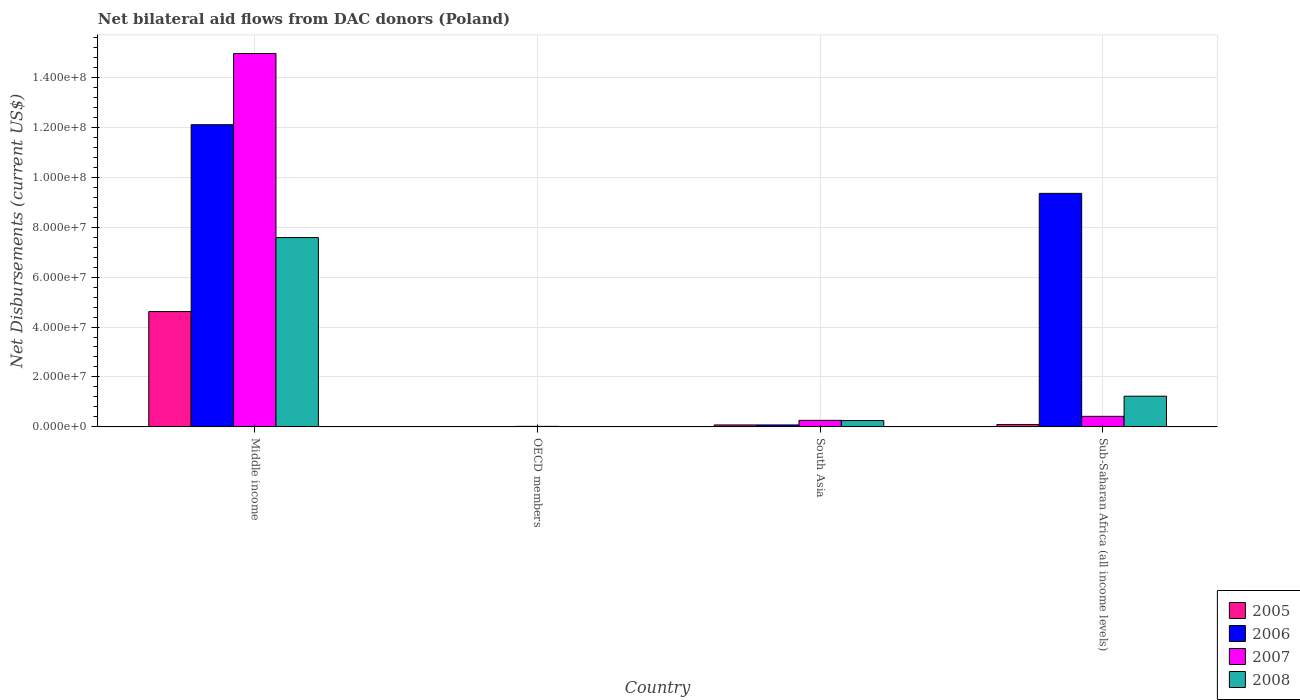How many bars are there on the 2nd tick from the left?
Ensure brevity in your answer.  4. In how many cases, is the number of bars for a given country not equal to the number of legend labels?
Offer a very short reply. 0. What is the net bilateral aid flows in 2006 in Middle income?
Provide a short and direct response. 1.21e+08. Across all countries, what is the maximum net bilateral aid flows in 2005?
Keep it short and to the point. 4.62e+07. Across all countries, what is the minimum net bilateral aid flows in 2005?
Offer a terse response. 5.00e+04. What is the total net bilateral aid flows in 2006 in the graph?
Your answer should be very brief. 2.15e+08. What is the difference between the net bilateral aid flows in 2005 in Middle income and that in Sub-Saharan Africa (all income levels)?
Make the answer very short. 4.52e+07. What is the difference between the net bilateral aid flows in 2007 in OECD members and the net bilateral aid flows in 2006 in South Asia?
Ensure brevity in your answer.  -5.60e+05. What is the average net bilateral aid flows in 2005 per country?
Your response must be concise. 1.20e+07. What is the difference between the net bilateral aid flows of/in 2005 and net bilateral aid flows of/in 2007 in Sub-Saharan Africa (all income levels)?
Provide a short and direct response. -3.26e+06. In how many countries, is the net bilateral aid flows in 2007 greater than 80000000 US$?
Provide a succinct answer. 1. What is the ratio of the net bilateral aid flows in 2008 in South Asia to that in Sub-Saharan Africa (all income levels)?
Offer a very short reply. 0.21. Is the net bilateral aid flows in 2007 in Middle income less than that in Sub-Saharan Africa (all income levels)?
Ensure brevity in your answer.  No. What is the difference between the highest and the second highest net bilateral aid flows in 2006?
Offer a terse response. 2.75e+07. What is the difference between the highest and the lowest net bilateral aid flows in 2008?
Your response must be concise. 7.57e+07. Is the sum of the net bilateral aid flows in 2008 in OECD members and Sub-Saharan Africa (all income levels) greater than the maximum net bilateral aid flows in 2006 across all countries?
Give a very brief answer. No. Is it the case that in every country, the sum of the net bilateral aid flows in 2006 and net bilateral aid flows in 2007 is greater than the net bilateral aid flows in 2005?
Your answer should be very brief. Yes. Are all the bars in the graph horizontal?
Ensure brevity in your answer.  No. How many countries are there in the graph?
Offer a very short reply. 4. Are the values on the major ticks of Y-axis written in scientific E-notation?
Give a very brief answer. Yes. Does the graph contain grids?
Keep it short and to the point. Yes. Where does the legend appear in the graph?
Keep it short and to the point. Bottom right. How many legend labels are there?
Your response must be concise. 4. What is the title of the graph?
Offer a very short reply. Net bilateral aid flows from DAC donors (Poland). What is the label or title of the X-axis?
Make the answer very short. Country. What is the label or title of the Y-axis?
Provide a succinct answer. Net Disbursements (current US$). What is the Net Disbursements (current US$) of 2005 in Middle income?
Offer a very short reply. 4.62e+07. What is the Net Disbursements (current US$) of 2006 in Middle income?
Make the answer very short. 1.21e+08. What is the Net Disbursements (current US$) of 2007 in Middle income?
Give a very brief answer. 1.50e+08. What is the Net Disbursements (current US$) of 2008 in Middle income?
Keep it short and to the point. 7.58e+07. What is the Net Disbursements (current US$) in 2005 in OECD members?
Your answer should be very brief. 5.00e+04. What is the Net Disbursements (current US$) of 2006 in OECD members?
Provide a succinct answer. 3.00e+04. What is the Net Disbursements (current US$) in 2007 in OECD members?
Your answer should be compact. 2.10e+05. What is the Net Disbursements (current US$) of 2005 in South Asia?
Offer a very short reply. 7.70e+05. What is the Net Disbursements (current US$) in 2006 in South Asia?
Your answer should be compact. 7.70e+05. What is the Net Disbursements (current US$) of 2007 in South Asia?
Offer a very short reply. 2.61e+06. What is the Net Disbursements (current US$) of 2008 in South Asia?
Make the answer very short. 2.54e+06. What is the Net Disbursements (current US$) of 2005 in Sub-Saharan Africa (all income levels)?
Your response must be concise. 9.60e+05. What is the Net Disbursements (current US$) of 2006 in Sub-Saharan Africa (all income levels)?
Provide a short and direct response. 9.35e+07. What is the Net Disbursements (current US$) in 2007 in Sub-Saharan Africa (all income levels)?
Keep it short and to the point. 4.22e+06. What is the Net Disbursements (current US$) of 2008 in Sub-Saharan Africa (all income levels)?
Ensure brevity in your answer.  1.23e+07. Across all countries, what is the maximum Net Disbursements (current US$) in 2005?
Your answer should be compact. 4.62e+07. Across all countries, what is the maximum Net Disbursements (current US$) of 2006?
Provide a succinct answer. 1.21e+08. Across all countries, what is the maximum Net Disbursements (current US$) of 2007?
Provide a short and direct response. 1.50e+08. Across all countries, what is the maximum Net Disbursements (current US$) of 2008?
Give a very brief answer. 7.58e+07. Across all countries, what is the minimum Net Disbursements (current US$) in 2008?
Your answer should be very brief. 1.40e+05. What is the total Net Disbursements (current US$) in 2005 in the graph?
Make the answer very short. 4.80e+07. What is the total Net Disbursements (current US$) in 2006 in the graph?
Offer a very short reply. 2.15e+08. What is the total Net Disbursements (current US$) in 2007 in the graph?
Make the answer very short. 1.57e+08. What is the total Net Disbursements (current US$) in 2008 in the graph?
Your answer should be compact. 9.08e+07. What is the difference between the Net Disbursements (current US$) in 2005 in Middle income and that in OECD members?
Your answer should be compact. 4.61e+07. What is the difference between the Net Disbursements (current US$) of 2006 in Middle income and that in OECD members?
Give a very brief answer. 1.21e+08. What is the difference between the Net Disbursements (current US$) in 2007 in Middle income and that in OECD members?
Give a very brief answer. 1.49e+08. What is the difference between the Net Disbursements (current US$) of 2008 in Middle income and that in OECD members?
Provide a short and direct response. 7.57e+07. What is the difference between the Net Disbursements (current US$) in 2005 in Middle income and that in South Asia?
Provide a succinct answer. 4.54e+07. What is the difference between the Net Disbursements (current US$) in 2006 in Middle income and that in South Asia?
Keep it short and to the point. 1.20e+08. What is the difference between the Net Disbursements (current US$) in 2007 in Middle income and that in South Asia?
Make the answer very short. 1.47e+08. What is the difference between the Net Disbursements (current US$) of 2008 in Middle income and that in South Asia?
Your answer should be very brief. 7.33e+07. What is the difference between the Net Disbursements (current US$) in 2005 in Middle income and that in Sub-Saharan Africa (all income levels)?
Provide a short and direct response. 4.52e+07. What is the difference between the Net Disbursements (current US$) of 2006 in Middle income and that in Sub-Saharan Africa (all income levels)?
Give a very brief answer. 2.75e+07. What is the difference between the Net Disbursements (current US$) in 2007 in Middle income and that in Sub-Saharan Africa (all income levels)?
Give a very brief answer. 1.45e+08. What is the difference between the Net Disbursements (current US$) of 2008 in Middle income and that in Sub-Saharan Africa (all income levels)?
Provide a succinct answer. 6.35e+07. What is the difference between the Net Disbursements (current US$) in 2005 in OECD members and that in South Asia?
Ensure brevity in your answer.  -7.20e+05. What is the difference between the Net Disbursements (current US$) in 2006 in OECD members and that in South Asia?
Give a very brief answer. -7.40e+05. What is the difference between the Net Disbursements (current US$) of 2007 in OECD members and that in South Asia?
Your response must be concise. -2.40e+06. What is the difference between the Net Disbursements (current US$) in 2008 in OECD members and that in South Asia?
Ensure brevity in your answer.  -2.40e+06. What is the difference between the Net Disbursements (current US$) in 2005 in OECD members and that in Sub-Saharan Africa (all income levels)?
Provide a succinct answer. -9.10e+05. What is the difference between the Net Disbursements (current US$) of 2006 in OECD members and that in Sub-Saharan Africa (all income levels)?
Provide a succinct answer. -9.35e+07. What is the difference between the Net Disbursements (current US$) in 2007 in OECD members and that in Sub-Saharan Africa (all income levels)?
Make the answer very short. -4.01e+06. What is the difference between the Net Disbursements (current US$) of 2008 in OECD members and that in Sub-Saharan Africa (all income levels)?
Keep it short and to the point. -1.22e+07. What is the difference between the Net Disbursements (current US$) in 2006 in South Asia and that in Sub-Saharan Africa (all income levels)?
Ensure brevity in your answer.  -9.28e+07. What is the difference between the Net Disbursements (current US$) in 2007 in South Asia and that in Sub-Saharan Africa (all income levels)?
Your response must be concise. -1.61e+06. What is the difference between the Net Disbursements (current US$) in 2008 in South Asia and that in Sub-Saharan Africa (all income levels)?
Provide a succinct answer. -9.75e+06. What is the difference between the Net Disbursements (current US$) in 2005 in Middle income and the Net Disbursements (current US$) in 2006 in OECD members?
Your response must be concise. 4.62e+07. What is the difference between the Net Disbursements (current US$) in 2005 in Middle income and the Net Disbursements (current US$) in 2007 in OECD members?
Ensure brevity in your answer.  4.60e+07. What is the difference between the Net Disbursements (current US$) in 2005 in Middle income and the Net Disbursements (current US$) in 2008 in OECD members?
Provide a succinct answer. 4.60e+07. What is the difference between the Net Disbursements (current US$) in 2006 in Middle income and the Net Disbursements (current US$) in 2007 in OECD members?
Give a very brief answer. 1.21e+08. What is the difference between the Net Disbursements (current US$) in 2006 in Middle income and the Net Disbursements (current US$) in 2008 in OECD members?
Your answer should be very brief. 1.21e+08. What is the difference between the Net Disbursements (current US$) in 2007 in Middle income and the Net Disbursements (current US$) in 2008 in OECD members?
Ensure brevity in your answer.  1.49e+08. What is the difference between the Net Disbursements (current US$) in 2005 in Middle income and the Net Disbursements (current US$) in 2006 in South Asia?
Provide a short and direct response. 4.54e+07. What is the difference between the Net Disbursements (current US$) in 2005 in Middle income and the Net Disbursements (current US$) in 2007 in South Asia?
Your response must be concise. 4.36e+07. What is the difference between the Net Disbursements (current US$) of 2005 in Middle income and the Net Disbursements (current US$) of 2008 in South Asia?
Your answer should be very brief. 4.36e+07. What is the difference between the Net Disbursements (current US$) of 2006 in Middle income and the Net Disbursements (current US$) of 2007 in South Asia?
Provide a short and direct response. 1.18e+08. What is the difference between the Net Disbursements (current US$) of 2006 in Middle income and the Net Disbursements (current US$) of 2008 in South Asia?
Give a very brief answer. 1.18e+08. What is the difference between the Net Disbursements (current US$) in 2007 in Middle income and the Net Disbursements (current US$) in 2008 in South Asia?
Your answer should be compact. 1.47e+08. What is the difference between the Net Disbursements (current US$) of 2005 in Middle income and the Net Disbursements (current US$) of 2006 in Sub-Saharan Africa (all income levels)?
Provide a short and direct response. -4.74e+07. What is the difference between the Net Disbursements (current US$) of 2005 in Middle income and the Net Disbursements (current US$) of 2007 in Sub-Saharan Africa (all income levels)?
Provide a short and direct response. 4.20e+07. What is the difference between the Net Disbursements (current US$) in 2005 in Middle income and the Net Disbursements (current US$) in 2008 in Sub-Saharan Africa (all income levels)?
Your answer should be compact. 3.39e+07. What is the difference between the Net Disbursements (current US$) in 2006 in Middle income and the Net Disbursements (current US$) in 2007 in Sub-Saharan Africa (all income levels)?
Offer a very short reply. 1.17e+08. What is the difference between the Net Disbursements (current US$) in 2006 in Middle income and the Net Disbursements (current US$) in 2008 in Sub-Saharan Africa (all income levels)?
Make the answer very short. 1.09e+08. What is the difference between the Net Disbursements (current US$) in 2007 in Middle income and the Net Disbursements (current US$) in 2008 in Sub-Saharan Africa (all income levels)?
Give a very brief answer. 1.37e+08. What is the difference between the Net Disbursements (current US$) in 2005 in OECD members and the Net Disbursements (current US$) in 2006 in South Asia?
Your response must be concise. -7.20e+05. What is the difference between the Net Disbursements (current US$) in 2005 in OECD members and the Net Disbursements (current US$) in 2007 in South Asia?
Ensure brevity in your answer.  -2.56e+06. What is the difference between the Net Disbursements (current US$) in 2005 in OECD members and the Net Disbursements (current US$) in 2008 in South Asia?
Keep it short and to the point. -2.49e+06. What is the difference between the Net Disbursements (current US$) of 2006 in OECD members and the Net Disbursements (current US$) of 2007 in South Asia?
Make the answer very short. -2.58e+06. What is the difference between the Net Disbursements (current US$) of 2006 in OECD members and the Net Disbursements (current US$) of 2008 in South Asia?
Ensure brevity in your answer.  -2.51e+06. What is the difference between the Net Disbursements (current US$) of 2007 in OECD members and the Net Disbursements (current US$) of 2008 in South Asia?
Give a very brief answer. -2.33e+06. What is the difference between the Net Disbursements (current US$) in 2005 in OECD members and the Net Disbursements (current US$) in 2006 in Sub-Saharan Africa (all income levels)?
Your answer should be compact. -9.35e+07. What is the difference between the Net Disbursements (current US$) in 2005 in OECD members and the Net Disbursements (current US$) in 2007 in Sub-Saharan Africa (all income levels)?
Keep it short and to the point. -4.17e+06. What is the difference between the Net Disbursements (current US$) in 2005 in OECD members and the Net Disbursements (current US$) in 2008 in Sub-Saharan Africa (all income levels)?
Offer a terse response. -1.22e+07. What is the difference between the Net Disbursements (current US$) of 2006 in OECD members and the Net Disbursements (current US$) of 2007 in Sub-Saharan Africa (all income levels)?
Keep it short and to the point. -4.19e+06. What is the difference between the Net Disbursements (current US$) of 2006 in OECD members and the Net Disbursements (current US$) of 2008 in Sub-Saharan Africa (all income levels)?
Offer a very short reply. -1.23e+07. What is the difference between the Net Disbursements (current US$) in 2007 in OECD members and the Net Disbursements (current US$) in 2008 in Sub-Saharan Africa (all income levels)?
Give a very brief answer. -1.21e+07. What is the difference between the Net Disbursements (current US$) of 2005 in South Asia and the Net Disbursements (current US$) of 2006 in Sub-Saharan Africa (all income levels)?
Give a very brief answer. -9.28e+07. What is the difference between the Net Disbursements (current US$) in 2005 in South Asia and the Net Disbursements (current US$) in 2007 in Sub-Saharan Africa (all income levels)?
Offer a terse response. -3.45e+06. What is the difference between the Net Disbursements (current US$) in 2005 in South Asia and the Net Disbursements (current US$) in 2008 in Sub-Saharan Africa (all income levels)?
Provide a succinct answer. -1.15e+07. What is the difference between the Net Disbursements (current US$) of 2006 in South Asia and the Net Disbursements (current US$) of 2007 in Sub-Saharan Africa (all income levels)?
Provide a short and direct response. -3.45e+06. What is the difference between the Net Disbursements (current US$) in 2006 in South Asia and the Net Disbursements (current US$) in 2008 in Sub-Saharan Africa (all income levels)?
Your answer should be compact. -1.15e+07. What is the difference between the Net Disbursements (current US$) in 2007 in South Asia and the Net Disbursements (current US$) in 2008 in Sub-Saharan Africa (all income levels)?
Make the answer very short. -9.68e+06. What is the average Net Disbursements (current US$) in 2005 per country?
Give a very brief answer. 1.20e+07. What is the average Net Disbursements (current US$) of 2006 per country?
Keep it short and to the point. 5.38e+07. What is the average Net Disbursements (current US$) in 2007 per country?
Offer a terse response. 3.91e+07. What is the average Net Disbursements (current US$) in 2008 per country?
Offer a terse response. 2.27e+07. What is the difference between the Net Disbursements (current US$) in 2005 and Net Disbursements (current US$) in 2006 in Middle income?
Provide a short and direct response. -7.48e+07. What is the difference between the Net Disbursements (current US$) of 2005 and Net Disbursements (current US$) of 2007 in Middle income?
Give a very brief answer. -1.03e+08. What is the difference between the Net Disbursements (current US$) in 2005 and Net Disbursements (current US$) in 2008 in Middle income?
Your answer should be compact. -2.96e+07. What is the difference between the Net Disbursements (current US$) of 2006 and Net Disbursements (current US$) of 2007 in Middle income?
Offer a terse response. -2.85e+07. What is the difference between the Net Disbursements (current US$) of 2006 and Net Disbursements (current US$) of 2008 in Middle income?
Ensure brevity in your answer.  4.52e+07. What is the difference between the Net Disbursements (current US$) in 2007 and Net Disbursements (current US$) in 2008 in Middle income?
Provide a succinct answer. 7.37e+07. What is the difference between the Net Disbursements (current US$) in 2005 and Net Disbursements (current US$) in 2007 in OECD members?
Your answer should be very brief. -1.60e+05. What is the difference between the Net Disbursements (current US$) in 2006 and Net Disbursements (current US$) in 2008 in OECD members?
Provide a short and direct response. -1.10e+05. What is the difference between the Net Disbursements (current US$) in 2007 and Net Disbursements (current US$) in 2008 in OECD members?
Keep it short and to the point. 7.00e+04. What is the difference between the Net Disbursements (current US$) in 2005 and Net Disbursements (current US$) in 2006 in South Asia?
Make the answer very short. 0. What is the difference between the Net Disbursements (current US$) of 2005 and Net Disbursements (current US$) of 2007 in South Asia?
Provide a succinct answer. -1.84e+06. What is the difference between the Net Disbursements (current US$) in 2005 and Net Disbursements (current US$) in 2008 in South Asia?
Ensure brevity in your answer.  -1.77e+06. What is the difference between the Net Disbursements (current US$) in 2006 and Net Disbursements (current US$) in 2007 in South Asia?
Offer a very short reply. -1.84e+06. What is the difference between the Net Disbursements (current US$) of 2006 and Net Disbursements (current US$) of 2008 in South Asia?
Your answer should be compact. -1.77e+06. What is the difference between the Net Disbursements (current US$) of 2007 and Net Disbursements (current US$) of 2008 in South Asia?
Ensure brevity in your answer.  7.00e+04. What is the difference between the Net Disbursements (current US$) of 2005 and Net Disbursements (current US$) of 2006 in Sub-Saharan Africa (all income levels)?
Offer a terse response. -9.26e+07. What is the difference between the Net Disbursements (current US$) in 2005 and Net Disbursements (current US$) in 2007 in Sub-Saharan Africa (all income levels)?
Give a very brief answer. -3.26e+06. What is the difference between the Net Disbursements (current US$) of 2005 and Net Disbursements (current US$) of 2008 in Sub-Saharan Africa (all income levels)?
Make the answer very short. -1.13e+07. What is the difference between the Net Disbursements (current US$) of 2006 and Net Disbursements (current US$) of 2007 in Sub-Saharan Africa (all income levels)?
Your answer should be very brief. 8.93e+07. What is the difference between the Net Disbursements (current US$) in 2006 and Net Disbursements (current US$) in 2008 in Sub-Saharan Africa (all income levels)?
Your answer should be compact. 8.12e+07. What is the difference between the Net Disbursements (current US$) in 2007 and Net Disbursements (current US$) in 2008 in Sub-Saharan Africa (all income levels)?
Provide a succinct answer. -8.07e+06. What is the ratio of the Net Disbursements (current US$) of 2005 in Middle income to that in OECD members?
Offer a terse response. 923.8. What is the ratio of the Net Disbursements (current US$) of 2006 in Middle income to that in OECD members?
Offer a very short reply. 4034.67. What is the ratio of the Net Disbursements (current US$) in 2007 in Middle income to that in OECD members?
Your answer should be compact. 712.14. What is the ratio of the Net Disbursements (current US$) in 2008 in Middle income to that in OECD members?
Provide a short and direct response. 541.64. What is the ratio of the Net Disbursements (current US$) of 2005 in Middle income to that in South Asia?
Provide a short and direct response. 59.99. What is the ratio of the Net Disbursements (current US$) in 2006 in Middle income to that in South Asia?
Provide a succinct answer. 157.19. What is the ratio of the Net Disbursements (current US$) of 2007 in Middle income to that in South Asia?
Your response must be concise. 57.3. What is the ratio of the Net Disbursements (current US$) of 2008 in Middle income to that in South Asia?
Give a very brief answer. 29.85. What is the ratio of the Net Disbursements (current US$) of 2005 in Middle income to that in Sub-Saharan Africa (all income levels)?
Ensure brevity in your answer.  48.11. What is the ratio of the Net Disbursements (current US$) in 2006 in Middle income to that in Sub-Saharan Africa (all income levels)?
Provide a short and direct response. 1.29. What is the ratio of the Net Disbursements (current US$) in 2007 in Middle income to that in Sub-Saharan Africa (all income levels)?
Provide a short and direct response. 35.44. What is the ratio of the Net Disbursements (current US$) of 2008 in Middle income to that in Sub-Saharan Africa (all income levels)?
Make the answer very short. 6.17. What is the ratio of the Net Disbursements (current US$) of 2005 in OECD members to that in South Asia?
Give a very brief answer. 0.06. What is the ratio of the Net Disbursements (current US$) of 2006 in OECD members to that in South Asia?
Your answer should be compact. 0.04. What is the ratio of the Net Disbursements (current US$) of 2007 in OECD members to that in South Asia?
Your answer should be compact. 0.08. What is the ratio of the Net Disbursements (current US$) in 2008 in OECD members to that in South Asia?
Make the answer very short. 0.06. What is the ratio of the Net Disbursements (current US$) of 2005 in OECD members to that in Sub-Saharan Africa (all income levels)?
Your answer should be very brief. 0.05. What is the ratio of the Net Disbursements (current US$) in 2007 in OECD members to that in Sub-Saharan Africa (all income levels)?
Your answer should be very brief. 0.05. What is the ratio of the Net Disbursements (current US$) of 2008 in OECD members to that in Sub-Saharan Africa (all income levels)?
Keep it short and to the point. 0.01. What is the ratio of the Net Disbursements (current US$) of 2005 in South Asia to that in Sub-Saharan Africa (all income levels)?
Provide a succinct answer. 0.8. What is the ratio of the Net Disbursements (current US$) of 2006 in South Asia to that in Sub-Saharan Africa (all income levels)?
Provide a short and direct response. 0.01. What is the ratio of the Net Disbursements (current US$) in 2007 in South Asia to that in Sub-Saharan Africa (all income levels)?
Provide a succinct answer. 0.62. What is the ratio of the Net Disbursements (current US$) in 2008 in South Asia to that in Sub-Saharan Africa (all income levels)?
Keep it short and to the point. 0.21. What is the difference between the highest and the second highest Net Disbursements (current US$) in 2005?
Provide a short and direct response. 4.52e+07. What is the difference between the highest and the second highest Net Disbursements (current US$) of 2006?
Provide a short and direct response. 2.75e+07. What is the difference between the highest and the second highest Net Disbursements (current US$) in 2007?
Offer a very short reply. 1.45e+08. What is the difference between the highest and the second highest Net Disbursements (current US$) of 2008?
Ensure brevity in your answer.  6.35e+07. What is the difference between the highest and the lowest Net Disbursements (current US$) in 2005?
Give a very brief answer. 4.61e+07. What is the difference between the highest and the lowest Net Disbursements (current US$) of 2006?
Your response must be concise. 1.21e+08. What is the difference between the highest and the lowest Net Disbursements (current US$) of 2007?
Offer a very short reply. 1.49e+08. What is the difference between the highest and the lowest Net Disbursements (current US$) of 2008?
Make the answer very short. 7.57e+07. 